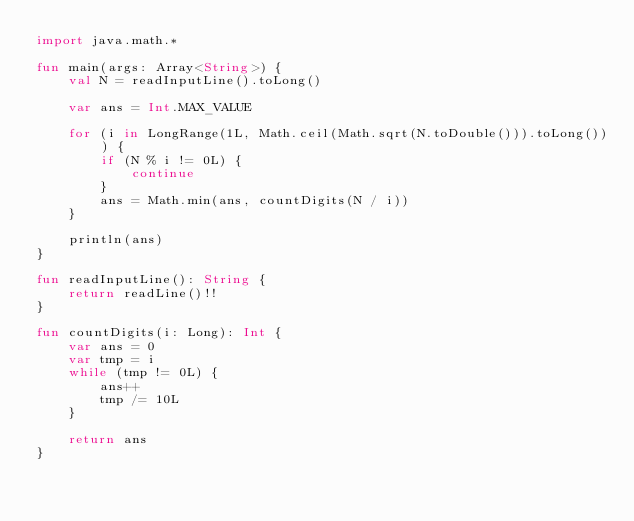Convert code to text. <code><loc_0><loc_0><loc_500><loc_500><_Kotlin_>import java.math.*

fun main(args: Array<String>) {
    val N = readInputLine().toLong()

    var ans = Int.MAX_VALUE

    for (i in LongRange(1L, Math.ceil(Math.sqrt(N.toDouble())).toLong())) {
        if (N % i != 0L) {
            continue
        }
        ans = Math.min(ans, countDigits(N / i))
    }

    println(ans)
}

fun readInputLine(): String {
    return readLine()!!
}

fun countDigits(i: Long): Int {
    var ans = 0
    var tmp = i
    while (tmp != 0L) {
        ans++
        tmp /= 10L
    }
    
    return ans
}
</code> 